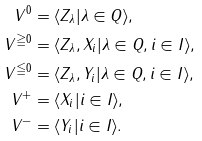<formula> <loc_0><loc_0><loc_500><loc_500>V ^ { 0 } & = \langle Z _ { \lambda } | \lambda \in Q \rangle , \\ V ^ { \geqq 0 } & = \langle Z _ { \lambda } , X _ { i } | \lambda \in Q , i \in I \rangle , \\ V ^ { \leqq 0 } & = \langle Z _ { \lambda } , Y _ { i } | \lambda \in Q , i \in I \rangle , \\ V ^ { + } & = \langle X _ { i } | i \in I \rangle , \\ V ^ { - } & = \langle Y _ { i } | i \in I \rangle .</formula> 